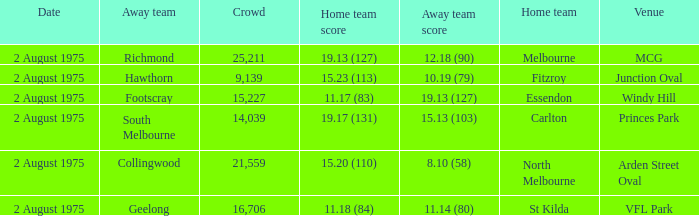Where did the home team score 11.18 (84)? VFL Park. 